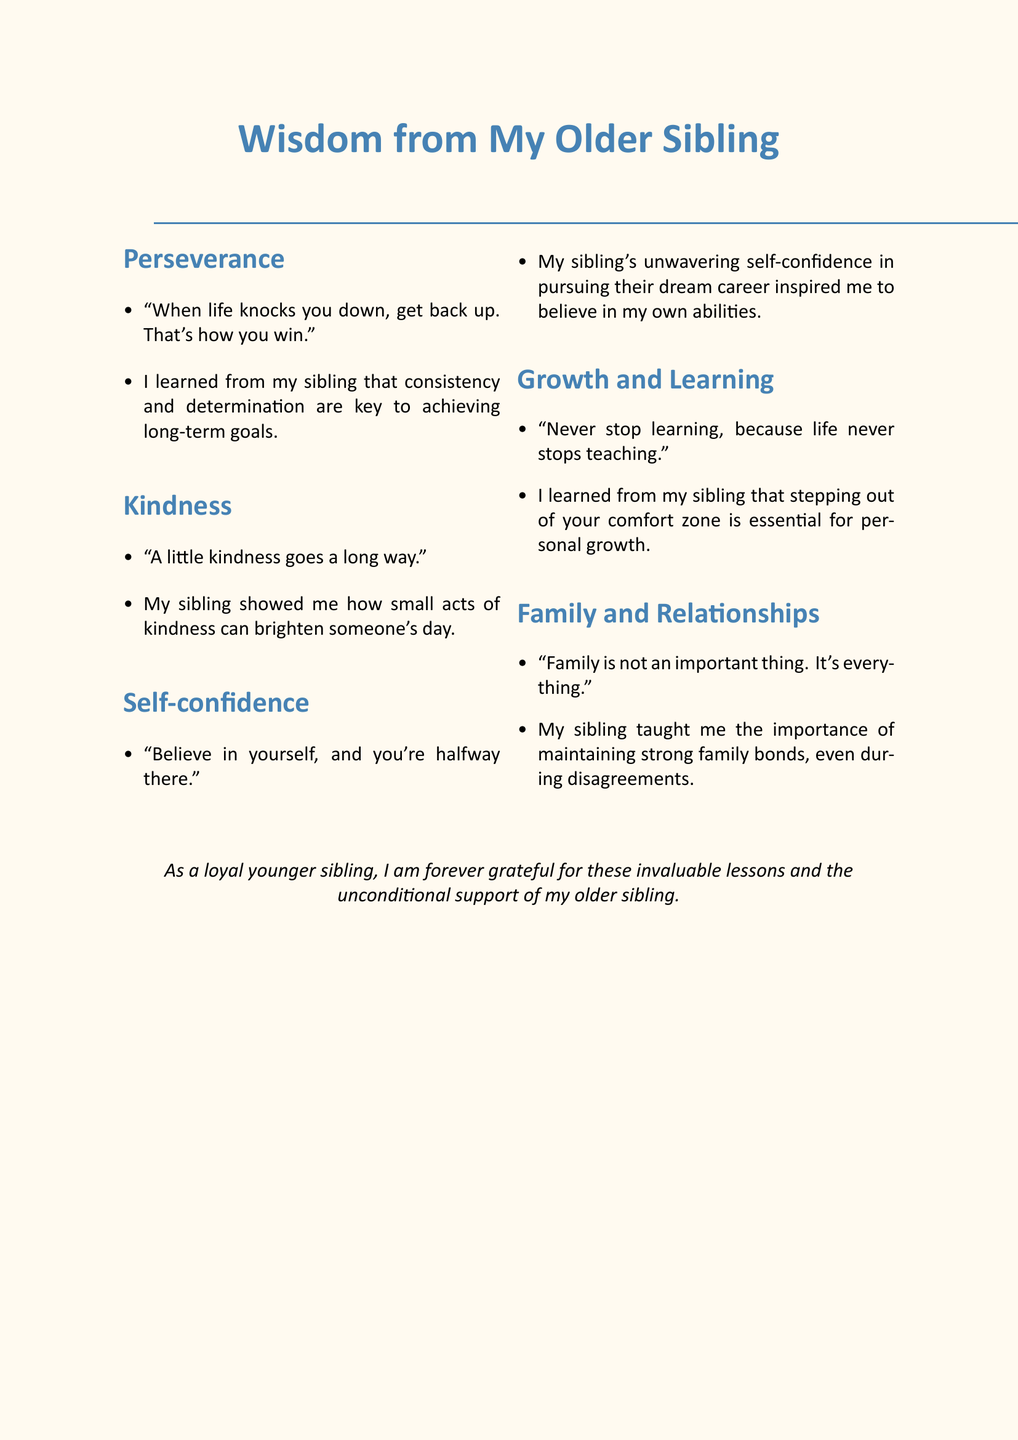What are the main themes covered in the document? The document organizes quotes and lessons into themes such as Perseverance, Kindness, Self-confidence, Growth and Learning, and Family and Relationships.
Answer: Perseverance, Kindness, Self-confidence, Growth and Learning, Family and Relationships Who shared the inspirational lessons? The document clearly states that these inspiring lessons were learned from an older sibling.
Answer: Older sibling What lesson is associated with the theme of Kindness? The document notes that being kind to others often leads to unexpected friendships.
Answer: Being kind to others often leads to unexpected friendships Which quote emphasizes the importance of self-confidence? The quote "Believe in yourself, and you're halfway there." highlights self-confidence in personal development.
Answer: Believe in yourself, and you're halfway there What lesson did the author learn about family bonds? The author mentions the importance of maintaining strong family bonds, even during disagreements.
Answer: Maintaining strong family bonds Name a quote related to Growth and Learning. The document includes the quote "Never stop learning, because life never stops teaching." that pertains to Growth and Learning.
Answer: Never stop learning, because life never stops teaching How many themes are discussed in the document? The themes listed in the document total five.
Answer: Five What quote reflects the idea of perseverance? The document features the quote "The only way to fail is to stop trying." which reflects perseverance.
Answer: The only way to fail is to stop trying What type of document is this? The context and formatting indicate that it is a memo focused on life lessons and quotes from an older sibling.
Answer: Memo 